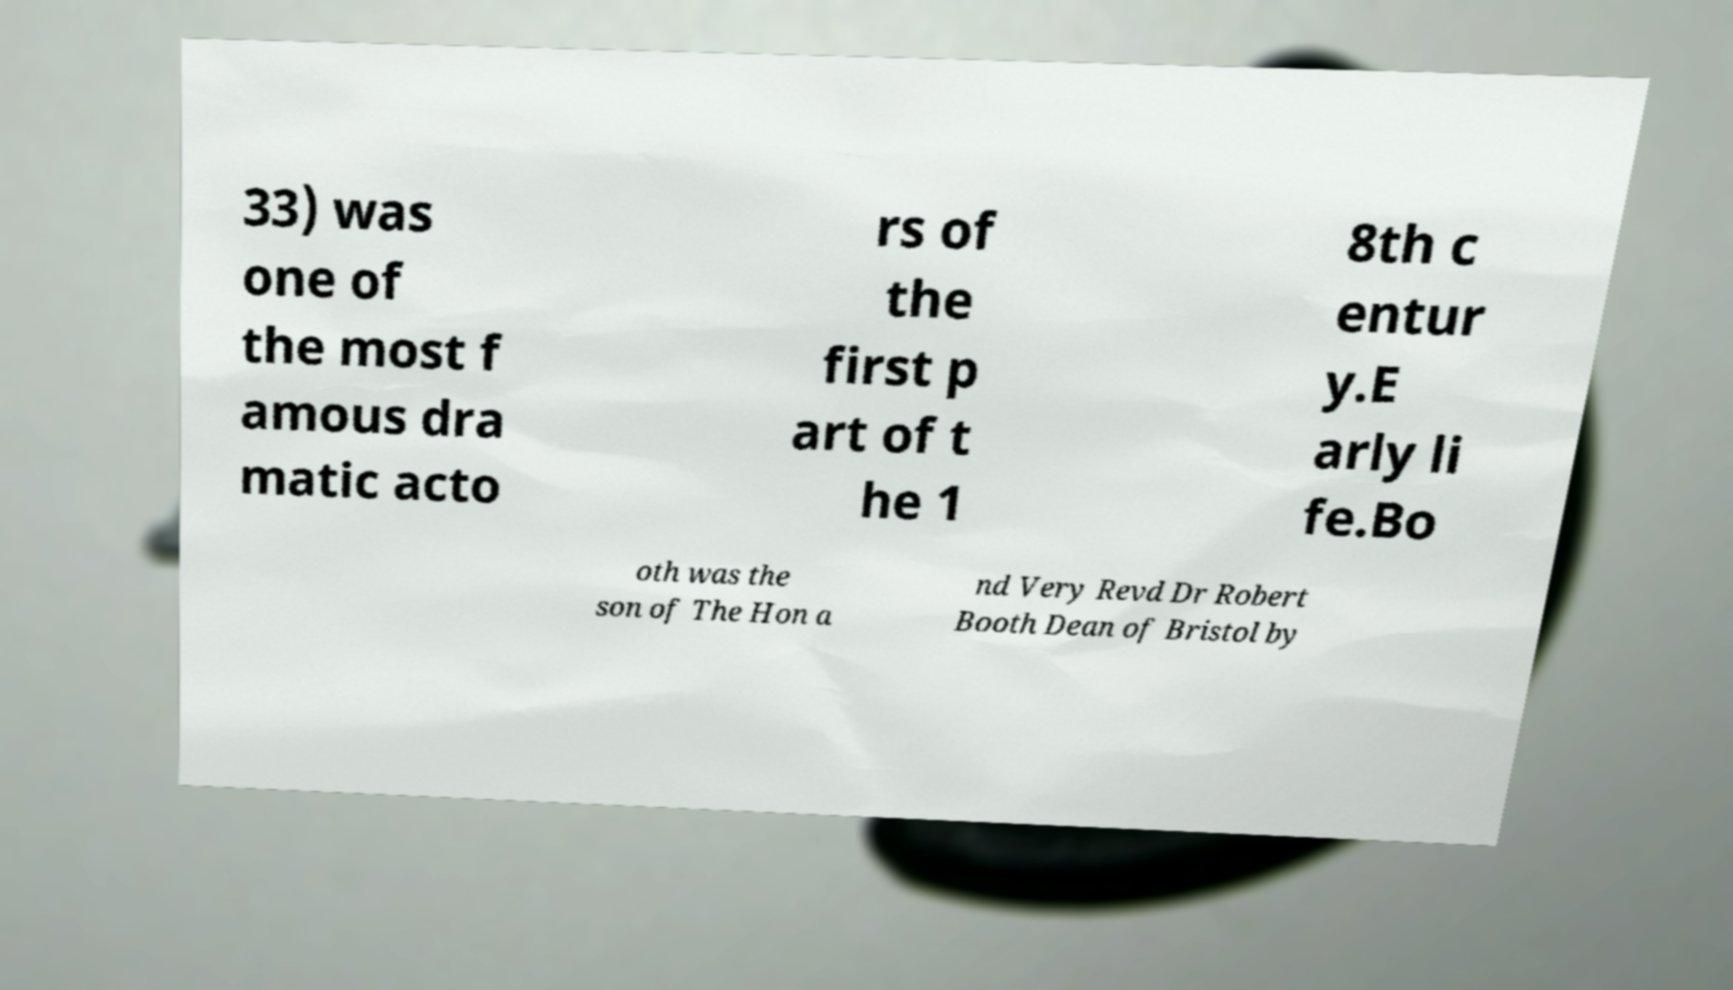What messages or text are displayed in this image? I need them in a readable, typed format. 33) was one of the most f amous dra matic acto rs of the first p art of t he 1 8th c entur y.E arly li fe.Bo oth was the son of The Hon a nd Very Revd Dr Robert Booth Dean of Bristol by 